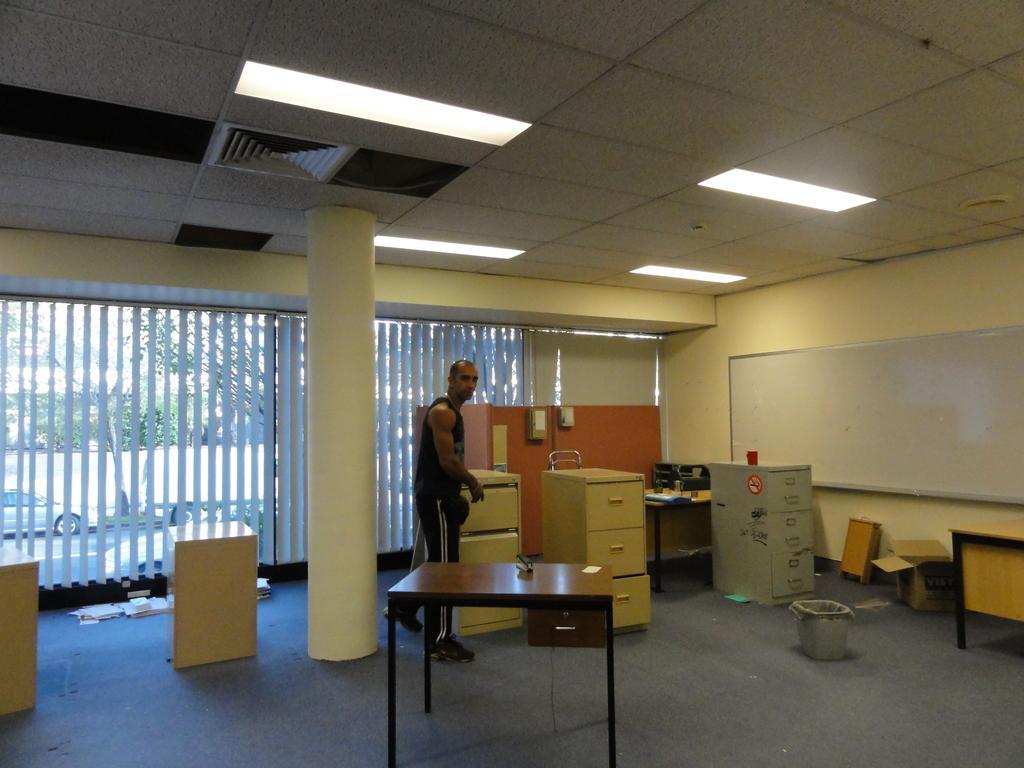Please provide a concise description of this image. Here we can see a person is standing on the floor, and in front here is the table, and here is the pillar, and here is the wall and board on it, and at above here are the lights. 